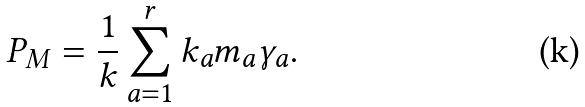<formula> <loc_0><loc_0><loc_500><loc_500>P _ { M } = \frac { 1 } { k } \sum _ { a = 1 } ^ { r } k _ { a } m _ { a } \gamma _ { a } .</formula> 